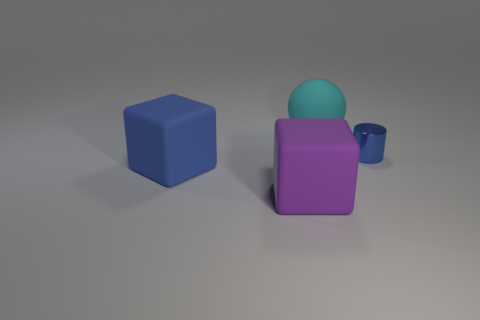The matte cube that is the same color as the shiny cylinder is what size?
Make the answer very short. Large. Are the blue thing right of the blue cube and the blue object that is to the left of the cyan object made of the same material?
Make the answer very short. No. What number of other objects are there of the same color as the matte sphere?
Offer a terse response. 0. What number of things are either blue objects that are in front of the tiny cylinder or rubber objects behind the large purple matte block?
Your answer should be very brief. 2. There is a rubber object behind the blue thing that is to the right of the cyan rubber object; how big is it?
Provide a short and direct response. Large. How big is the metallic thing?
Offer a terse response. Small. There is a tiny thing that is behind the large blue matte object; does it have the same color as the large cube on the left side of the purple matte block?
Offer a very short reply. Yes. What number of other objects are there of the same material as the cylinder?
Make the answer very short. 0. Is there a large blue block?
Your answer should be compact. Yes. Is the block in front of the large blue object made of the same material as the big blue cube?
Your answer should be very brief. Yes. 